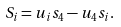<formula> <loc_0><loc_0><loc_500><loc_500>S _ { i } = u _ { i } s _ { 4 } - u _ { 4 } s _ { i } .</formula> 